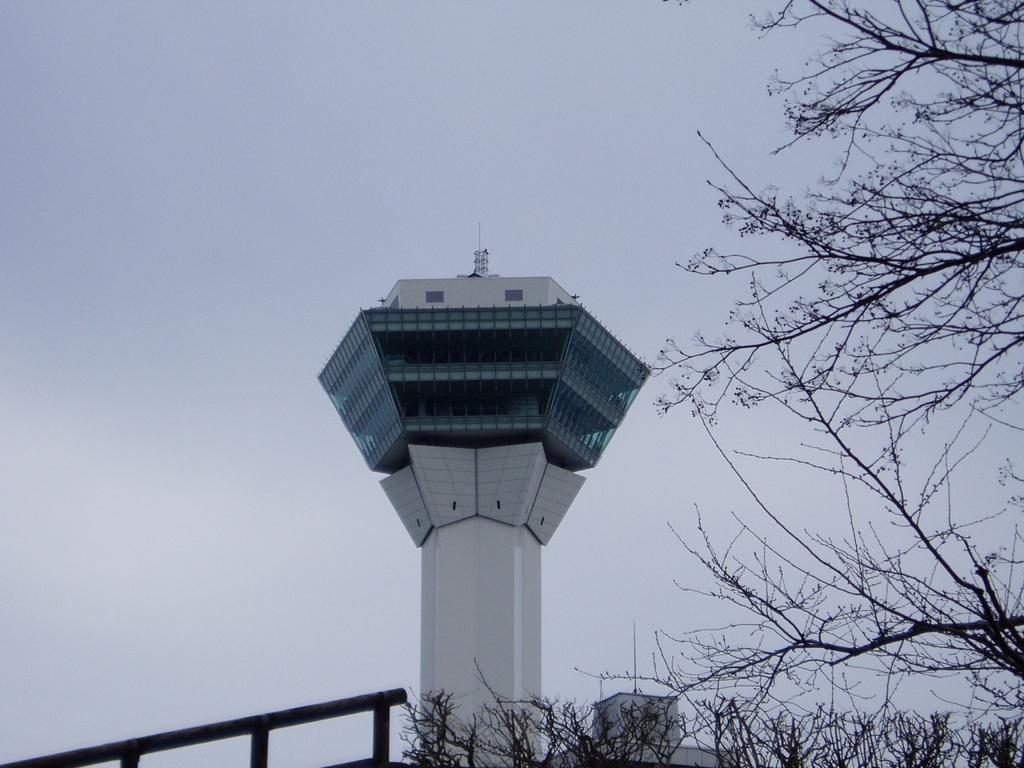What structure is located in the middle of the image? There is a tower in the middle of the image. What type of vegetation is on the right side of the image? There are trees on the right side of the image. What can be seen at the bottom of the image? There is a black railing at the bottom of the image. What is visible in the background of the image? The sky is visible in the background of the image. What part of the tower does the grandmother hold onto in the image? There is no grandmother present in the image, and therefore no such interaction can be observed. What idea does the tower represent in the image? The image does not convey any specific ideas or concepts related to the tower; it is simply a structure in the scene. 